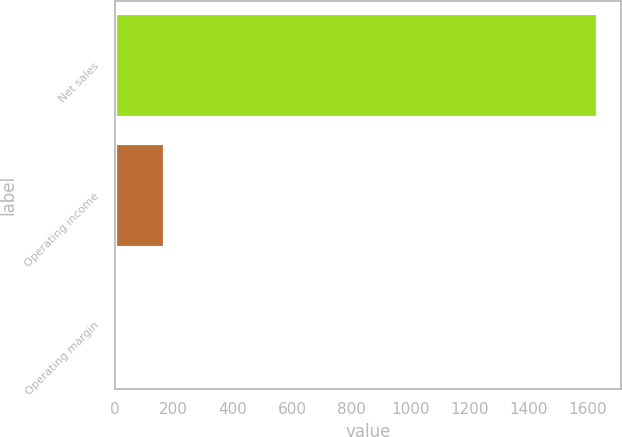Convert chart to OTSL. <chart><loc_0><loc_0><loc_500><loc_500><bar_chart><fcel>Net sales<fcel>Operating income<fcel>Operating margin<nl><fcel>1630<fcel>167.77<fcel>5.3<nl></chart> 